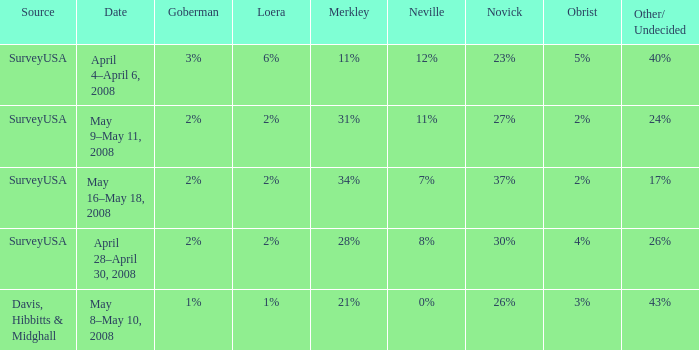Which Goberman has an Obrist of 2%, and a Merkley of 34%? 2%. 